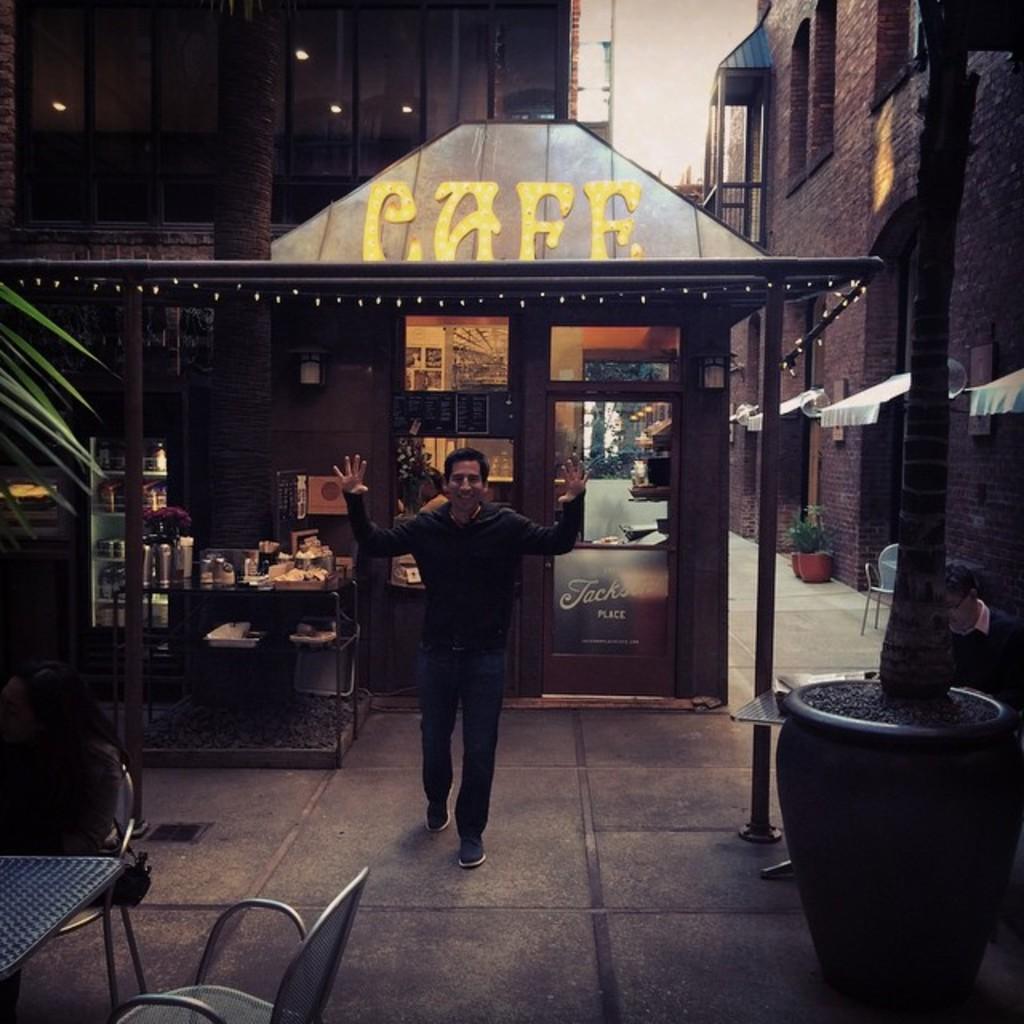Please provide a concise description of this image. In this picture I can see a man standing, there is a person sitting, there are chairs, tables and some other objects, there is a shop, refrigerator, there are plants and in the background there are buildings. 